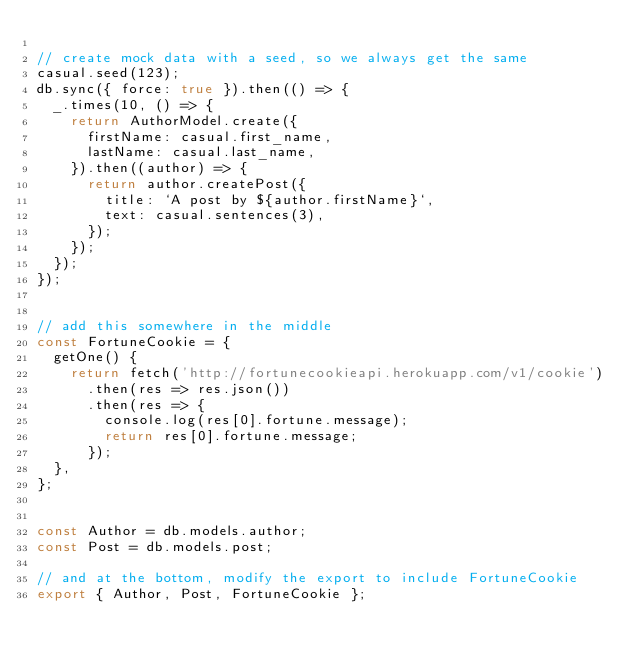<code> <loc_0><loc_0><loc_500><loc_500><_JavaScript_>
// create mock data with a seed, so we always get the same
casual.seed(123);
db.sync({ force: true }).then(() => {
  _.times(10, () => {
    return AuthorModel.create({
      firstName: casual.first_name,
      lastName: casual.last_name,
    }).then((author) => {
      return author.createPost({
        title: `A post by ${author.firstName}`,
        text: casual.sentences(3),
      });
    });
  });
});


// add this somewhere in the middle
const FortuneCookie = {
  getOne() {
    return fetch('http://fortunecookieapi.herokuapp.com/v1/cookie')
      .then(res => res.json())
      .then(res => {
        console.log(res[0].fortune.message);
        return res[0].fortune.message;
      });
  },
};


const Author = db.models.author;
const Post = db.models.post;

// and at the bottom, modify the export to include FortuneCookie
export { Author, Post, FortuneCookie };
</code> 